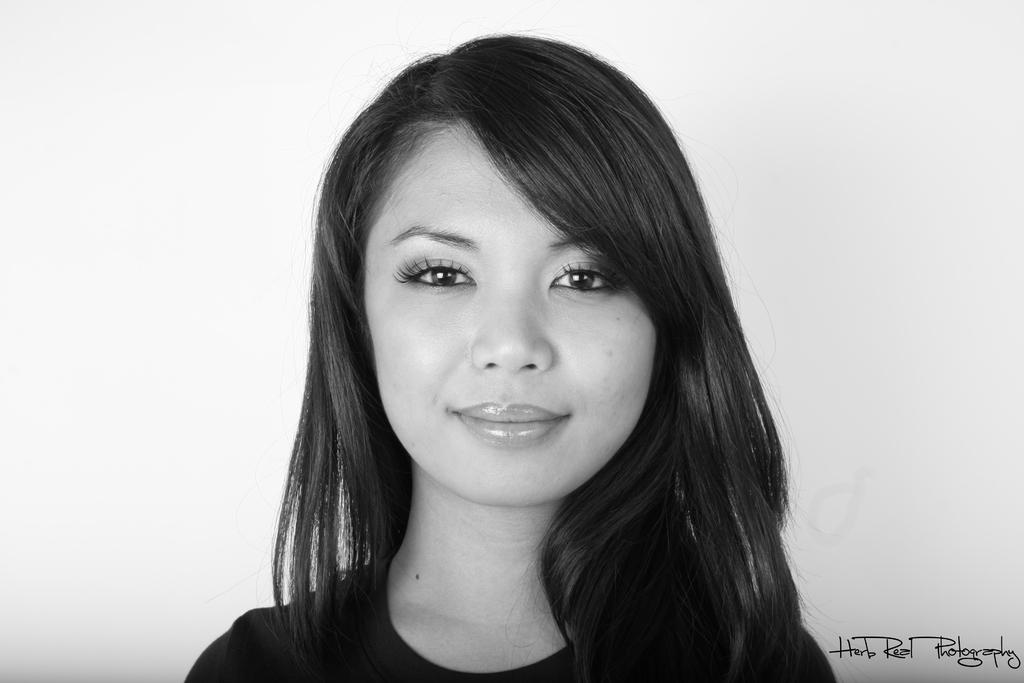What is the color scheme of the image? The image is black and white. Who is the main subject in the image? There is a girl in the center of the image. What can be found at the bottom of the image? There is text at the bottom of the image. What is visible in the background of the image? There is a wall in the background of the image. Can you see a boat in the image? There is no boat present in the image. How many beads are hanging from the girl's necklace in the image? There is no necklace or beads visible in the image. 